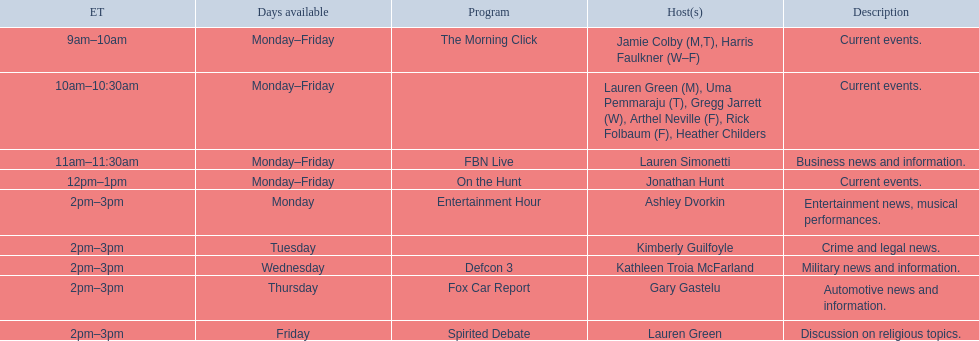Who are all the hosts? Jamie Colby (M,T), Harris Faulkner (W–F), Lauren Green (M), Uma Pemmaraju (T), Gregg Jarrett (W), Arthel Neville (F), Rick Folbaum (F), Heather Childers, Lauren Simonetti, Jonathan Hunt, Ashley Dvorkin, Kimberly Guilfoyle, Kathleen Troia McFarland, Gary Gastelu, Lauren Green. Which of them have a show on friday? Jamie Colby (M,T), Harris Faulkner (W–F), Lauren Green (M), Uma Pemmaraju (T), Gregg Jarrett (W), Arthel Neville (F), Rick Folbaum (F), Heather Childers, Lauren Simonetti, Jonathan Hunt, Lauren Green. And among them, which host is exclusively available on fridays? Lauren Green. 